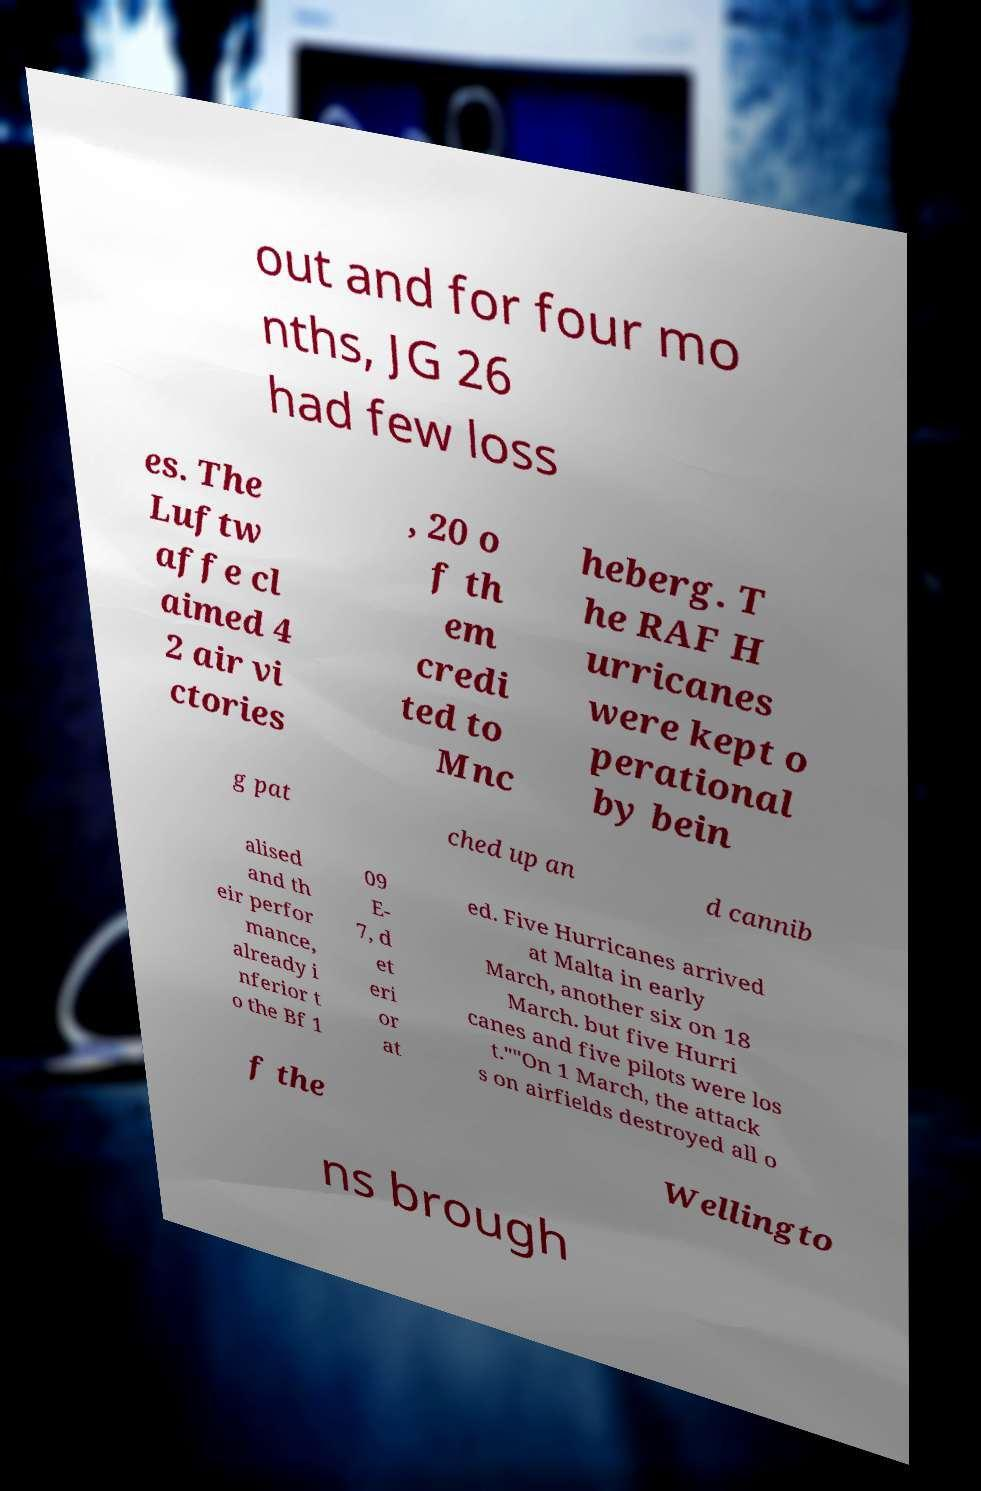For documentation purposes, I need the text within this image transcribed. Could you provide that? out and for four mo nths, JG 26 had few loss es. The Luftw affe cl aimed 4 2 air vi ctories , 20 o f th em credi ted to Mnc heberg. T he RAF H urricanes were kept o perational by bein g pat ched up an d cannib alised and th eir perfor mance, already i nferior t o the Bf 1 09 E- 7, d et eri or at ed. Five Hurricanes arrived at Malta in early March, another six on 18 March. but five Hurri canes and five pilots were los t.""On 1 March, the attack s on airfields destroyed all o f the Wellingto ns brough 